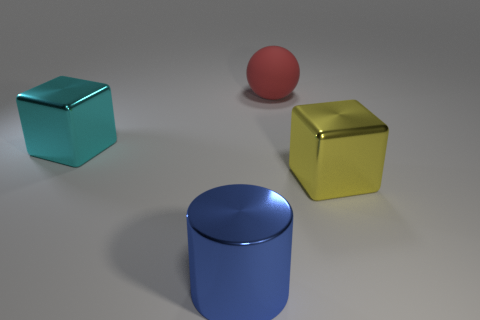Is there any other thing that has the same color as the sphere?
Offer a very short reply. No. There is a thing in front of the large yellow metallic cube; what size is it?
Make the answer very short. Large. There is a block on the left side of the thing that is in front of the big cube that is in front of the cyan shiny thing; what size is it?
Your answer should be very brief. Large. What is the color of the big cube that is to the right of the big cube to the left of the large blue metal cylinder?
Offer a terse response. Yellow. Is there anything else that has the same material as the big red ball?
Your answer should be compact. No. There is a big metal cylinder; are there any large cyan objects right of it?
Give a very brief answer. No. What number of blocks are there?
Offer a very short reply. 2. There is a shiny thing on the right side of the big ball; what number of cyan blocks are on the left side of it?
Ensure brevity in your answer.  1. What number of other big things are the same shape as the yellow shiny thing?
Your response must be concise. 1. There is a block that is on the left side of the big matte sphere; what material is it?
Your response must be concise. Metal. 